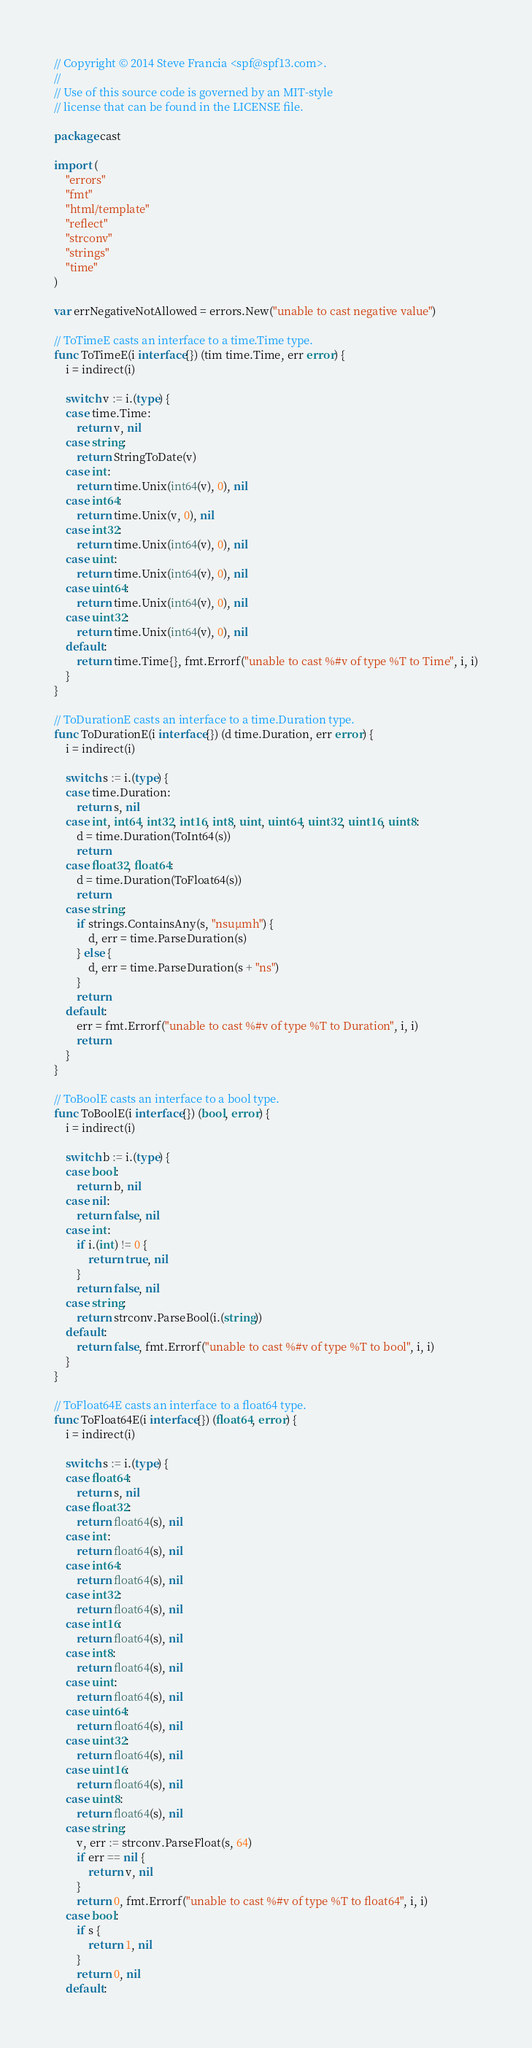<code> <loc_0><loc_0><loc_500><loc_500><_Go_>// Copyright © 2014 Steve Francia <spf@spf13.com>.
//
// Use of this source code is governed by an MIT-style
// license that can be found in the LICENSE file.

package cast

import (
	"errors"
	"fmt"
	"html/template"
	"reflect"
	"strconv"
	"strings"
	"time"
)

var errNegativeNotAllowed = errors.New("unable to cast negative value")

// ToTimeE casts an interface to a time.Time type.
func ToTimeE(i interface{}) (tim time.Time, err error) {
	i = indirect(i)

	switch v := i.(type) {
	case time.Time:
		return v, nil
	case string:
		return StringToDate(v)
	case int:
		return time.Unix(int64(v), 0), nil
	case int64:
		return time.Unix(v, 0), nil
	case int32:
		return time.Unix(int64(v), 0), nil
	case uint:
		return time.Unix(int64(v), 0), nil
	case uint64:
		return time.Unix(int64(v), 0), nil
	case uint32:
		return time.Unix(int64(v), 0), nil
	default:
		return time.Time{}, fmt.Errorf("unable to cast %#v of type %T to Time", i, i)
	}
}

// ToDurationE casts an interface to a time.Duration type.
func ToDurationE(i interface{}) (d time.Duration, err error) {
	i = indirect(i)

	switch s := i.(type) {
	case time.Duration:
		return s, nil
	case int, int64, int32, int16, int8, uint, uint64, uint32, uint16, uint8:
		d = time.Duration(ToInt64(s))
		return
	case float32, float64:
		d = time.Duration(ToFloat64(s))
		return
	case string:
		if strings.ContainsAny(s, "nsuµmh") {
			d, err = time.ParseDuration(s)
		} else {
			d, err = time.ParseDuration(s + "ns")
		}
		return
	default:
		err = fmt.Errorf("unable to cast %#v of type %T to Duration", i, i)
		return
	}
}

// ToBoolE casts an interface to a bool type.
func ToBoolE(i interface{}) (bool, error) {
	i = indirect(i)

	switch b := i.(type) {
	case bool:
		return b, nil
	case nil:
		return false, nil
	case int:
		if i.(int) != 0 {
			return true, nil
		}
		return false, nil
	case string:
		return strconv.ParseBool(i.(string))
	default:
		return false, fmt.Errorf("unable to cast %#v of type %T to bool", i, i)
	}
}

// ToFloat64E casts an interface to a float64 type.
func ToFloat64E(i interface{}) (float64, error) {
	i = indirect(i)

	switch s := i.(type) {
	case float64:
		return s, nil
	case float32:
		return float64(s), nil
	case int:
		return float64(s), nil
	case int64:
		return float64(s), nil
	case int32:
		return float64(s), nil
	case int16:
		return float64(s), nil
	case int8:
		return float64(s), nil
	case uint:
		return float64(s), nil
	case uint64:
		return float64(s), nil
	case uint32:
		return float64(s), nil
	case uint16:
		return float64(s), nil
	case uint8:
		return float64(s), nil
	case string:
		v, err := strconv.ParseFloat(s, 64)
		if err == nil {
			return v, nil
		}
		return 0, fmt.Errorf("unable to cast %#v of type %T to float64", i, i)
	case bool:
		if s {
			return 1, nil
		}
		return 0, nil
	default:</code> 